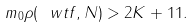<formula> <loc_0><loc_0><loc_500><loc_500>m _ { 0 } \rho ( \ w t { f } , N ) > 2 K + 1 1 .</formula> 